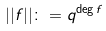<formula> <loc_0><loc_0><loc_500><loc_500>| | f | | \colon = q ^ { \deg f }</formula> 